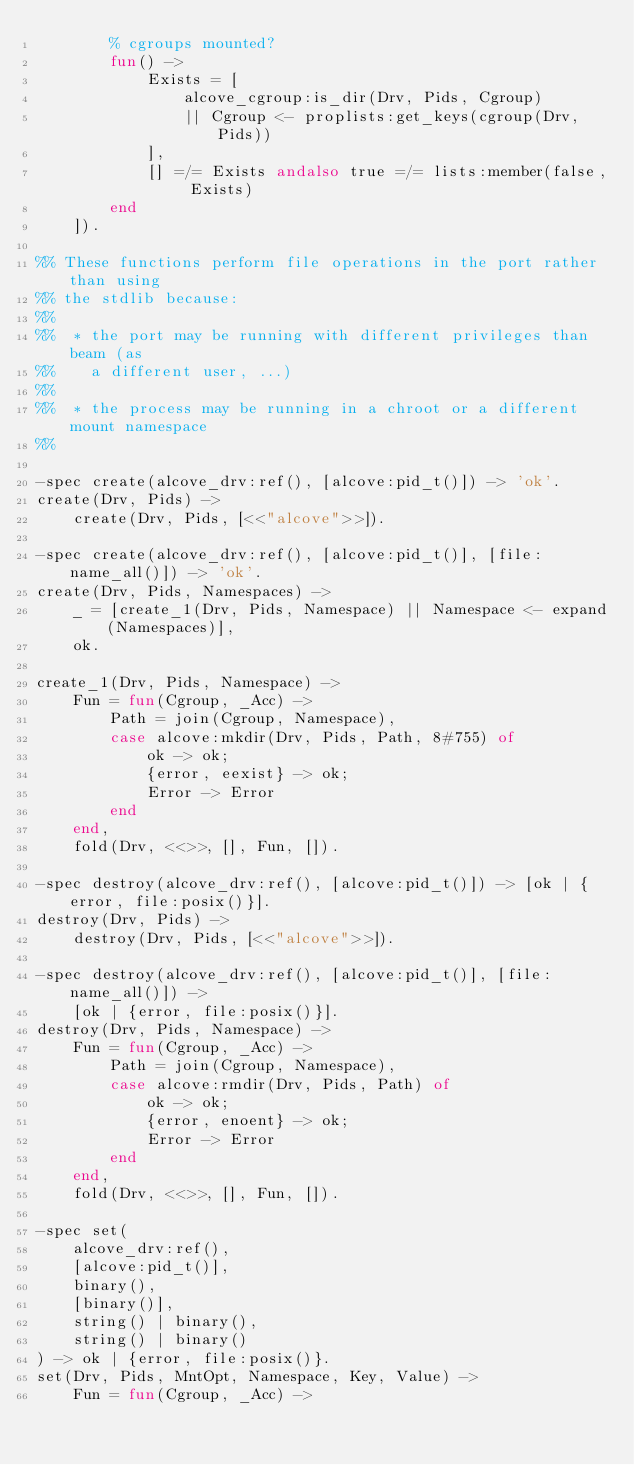<code> <loc_0><loc_0><loc_500><loc_500><_Erlang_>        % cgroups mounted?
        fun() ->
            Exists = [
                alcove_cgroup:is_dir(Drv, Pids, Cgroup)
                || Cgroup <- proplists:get_keys(cgroup(Drv, Pids))
            ],
            [] =/= Exists andalso true =/= lists:member(false, Exists)
        end
    ]).

%% These functions perform file operations in the port rather than using
%% the stdlib because:
%%
%%  * the port may be running with different privileges than beam (as
%%    a different user, ...)
%%
%%  * the process may be running in a chroot or a different mount namespace
%%

-spec create(alcove_drv:ref(), [alcove:pid_t()]) -> 'ok'.
create(Drv, Pids) ->
    create(Drv, Pids, [<<"alcove">>]).

-spec create(alcove_drv:ref(), [alcove:pid_t()], [file:name_all()]) -> 'ok'.
create(Drv, Pids, Namespaces) ->
    _ = [create_1(Drv, Pids, Namespace) || Namespace <- expand(Namespaces)],
    ok.

create_1(Drv, Pids, Namespace) ->
    Fun = fun(Cgroup, _Acc) ->
        Path = join(Cgroup, Namespace),
        case alcove:mkdir(Drv, Pids, Path, 8#755) of
            ok -> ok;
            {error, eexist} -> ok;
            Error -> Error
        end
    end,
    fold(Drv, <<>>, [], Fun, []).

-spec destroy(alcove_drv:ref(), [alcove:pid_t()]) -> [ok | {error, file:posix()}].
destroy(Drv, Pids) ->
    destroy(Drv, Pids, [<<"alcove">>]).

-spec destroy(alcove_drv:ref(), [alcove:pid_t()], [file:name_all()]) ->
    [ok | {error, file:posix()}].
destroy(Drv, Pids, Namespace) ->
    Fun = fun(Cgroup, _Acc) ->
        Path = join(Cgroup, Namespace),
        case alcove:rmdir(Drv, Pids, Path) of
            ok -> ok;
            {error, enoent} -> ok;
            Error -> Error
        end
    end,
    fold(Drv, <<>>, [], Fun, []).

-spec set(
    alcove_drv:ref(),
    [alcove:pid_t()],
    binary(),
    [binary()],
    string() | binary(),
    string() | binary()
) -> ok | {error, file:posix()}.
set(Drv, Pids, MntOpt, Namespace, Key, Value) ->
    Fun = fun(Cgroup, _Acc) -></code> 